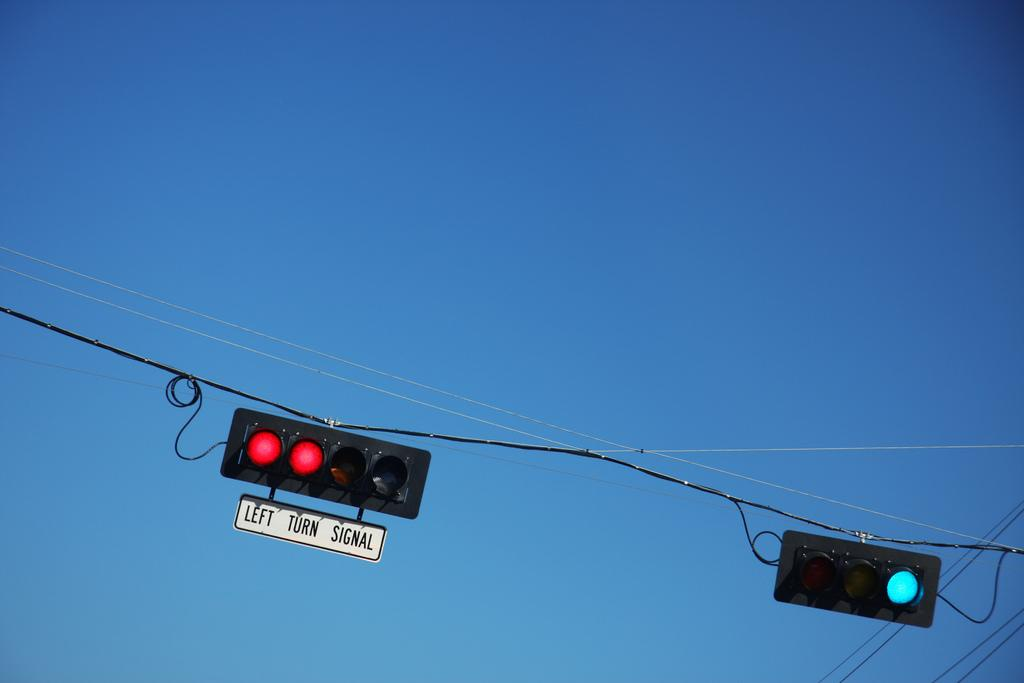Provide a one-sentence caption for the provided image. left turn signal underneath a light that is red. 